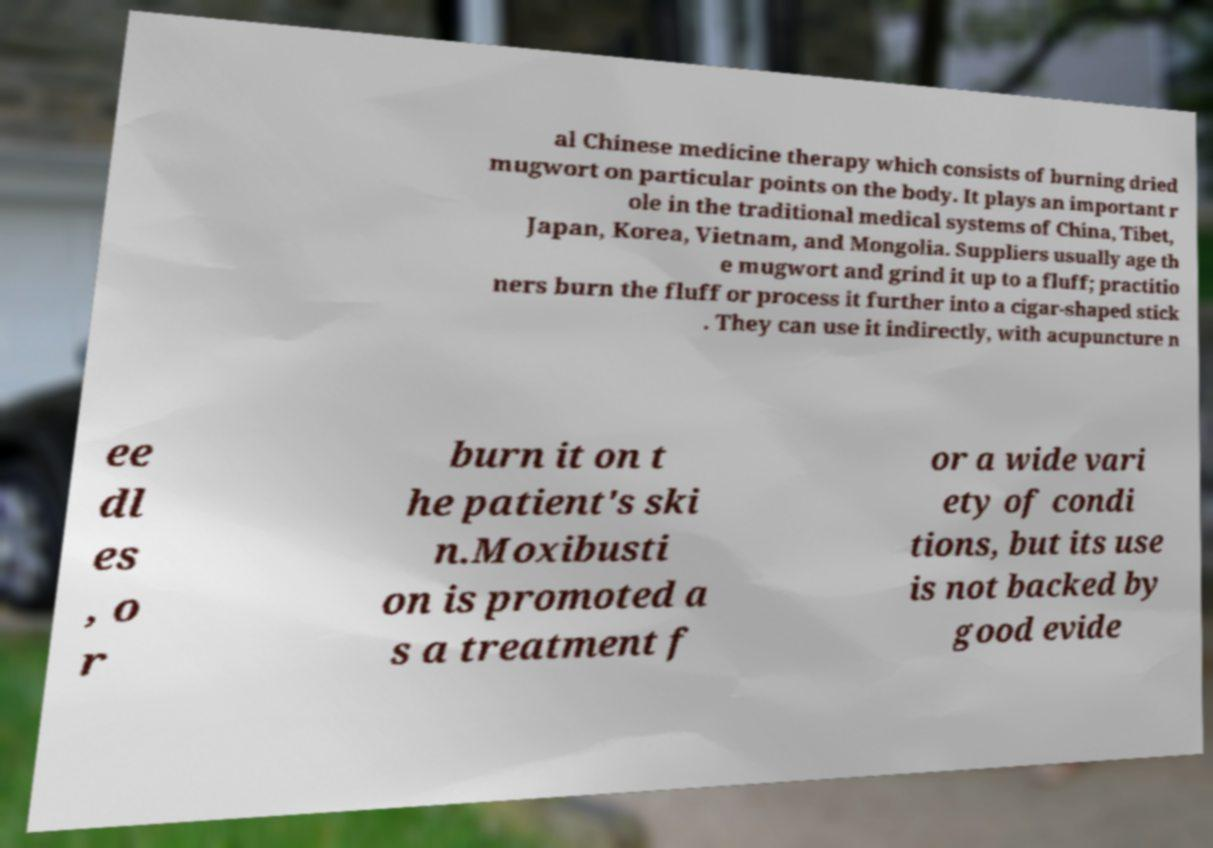Please identify and transcribe the text found in this image. al Chinese medicine therapy which consists of burning dried mugwort on particular points on the body. It plays an important r ole in the traditional medical systems of China, Tibet, Japan, Korea, Vietnam, and Mongolia. Suppliers usually age th e mugwort and grind it up to a fluff; practitio ners burn the fluff or process it further into a cigar-shaped stick . They can use it indirectly, with acupuncture n ee dl es , o r burn it on t he patient's ski n.Moxibusti on is promoted a s a treatment f or a wide vari ety of condi tions, but its use is not backed by good evide 